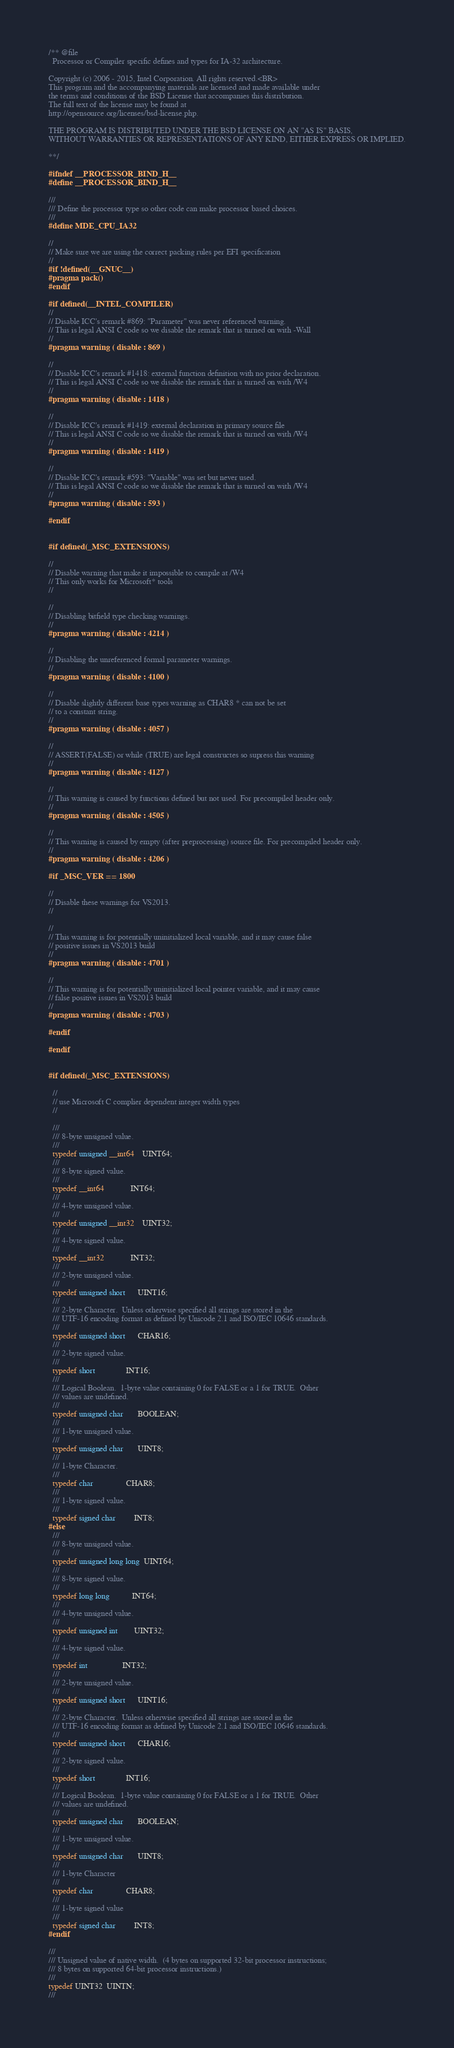<code> <loc_0><loc_0><loc_500><loc_500><_C_>/** @file
  Processor or Compiler specific defines and types for IA-32 architecture.

Copyright (c) 2006 - 2015, Intel Corporation. All rights reserved.<BR>
This program and the accompanying materials are licensed and made available under
the terms and conditions of the BSD License that accompanies this distribution.
The full text of the license may be found at
http://opensource.org/licenses/bsd-license.php.

THE PROGRAM IS DISTRIBUTED UNDER THE BSD LICENSE ON AN "AS IS" BASIS,
WITHOUT WARRANTIES OR REPRESENTATIONS OF ANY KIND, EITHER EXPRESS OR IMPLIED.

**/

#ifndef __PROCESSOR_BIND_H__
#define __PROCESSOR_BIND_H__

///
/// Define the processor type so other code can make processor based choices.
///
#define MDE_CPU_IA32

//
// Make sure we are using the correct packing rules per EFI specification
//
#if !defined(__GNUC__)
#pragma pack()
#endif

#if defined(__INTEL_COMPILER)
//
// Disable ICC's remark #869: "Parameter" was never referenced warning.
// This is legal ANSI C code so we disable the remark that is turned on with -Wall
//
#pragma warning ( disable : 869 )

//
// Disable ICC's remark #1418: external function definition with no prior declaration.
// This is legal ANSI C code so we disable the remark that is turned on with /W4
//
#pragma warning ( disable : 1418 )

//
// Disable ICC's remark #1419: external declaration in primary source file
// This is legal ANSI C code so we disable the remark that is turned on with /W4
//
#pragma warning ( disable : 1419 )

//
// Disable ICC's remark #593: "Variable" was set but never used.
// This is legal ANSI C code so we disable the remark that is turned on with /W4
//
#pragma warning ( disable : 593 )

#endif


#if defined(_MSC_EXTENSIONS)

//
// Disable warning that make it impossible to compile at /W4
// This only works for Microsoft* tools
//

//
// Disabling bitfield type checking warnings.
//
#pragma warning ( disable : 4214 )

//
// Disabling the unreferenced formal parameter warnings.
//
#pragma warning ( disable : 4100 )

//
// Disable slightly different base types warning as CHAR8 * can not be set
// to a constant string.
//
#pragma warning ( disable : 4057 )

//
// ASSERT(FALSE) or while (TRUE) are legal constructes so supress this warning
//
#pragma warning ( disable : 4127 )

//
// This warning is caused by functions defined but not used. For precompiled header only.
//
#pragma warning ( disable : 4505 )

//
// This warning is caused by empty (after preprocessing) source file. For precompiled header only.
//
#pragma warning ( disable : 4206 )

#if _MSC_VER == 1800

//
// Disable these warnings for VS2013.
//

//
// This warning is for potentially uninitialized local variable, and it may cause false
// positive issues in VS2013 build
//
#pragma warning ( disable : 4701 )

//
// This warning is for potentially uninitialized local pointer variable, and it may cause
// false positive issues in VS2013 build
//
#pragma warning ( disable : 4703 )

#endif

#endif


#if defined(_MSC_EXTENSIONS)

  //
  // use Microsoft C complier dependent integer width types
  //

  ///
  /// 8-byte unsigned value.
  ///
  typedef unsigned __int64    UINT64;
  ///
  /// 8-byte signed value.
  ///
  typedef __int64             INT64;
  ///
  /// 4-byte unsigned value.
  ///
  typedef unsigned __int32    UINT32;
  ///
  /// 4-byte signed value.
  ///
  typedef __int32             INT32;
  ///
  /// 2-byte unsigned value.
  ///
  typedef unsigned short      UINT16;
  ///
  /// 2-byte Character.  Unless otherwise specified all strings are stored in the
  /// UTF-16 encoding format as defined by Unicode 2.1 and ISO/IEC 10646 standards.
  ///
  typedef unsigned short      CHAR16;
  ///
  /// 2-byte signed value.
  ///
  typedef short               INT16;
  ///
  /// Logical Boolean.  1-byte value containing 0 for FALSE or a 1 for TRUE.  Other
  /// values are undefined.
  ///
  typedef unsigned char       BOOLEAN;
  ///
  /// 1-byte unsigned value.
  ///
  typedef unsigned char       UINT8;
  ///
  /// 1-byte Character.
  ///
  typedef char                CHAR8;
  ///
  /// 1-byte signed value.
  ///
  typedef signed char         INT8;
#else
  ///
  /// 8-byte unsigned value.
  ///
  typedef unsigned long long  UINT64;
  ///
  /// 8-byte signed value.
  ///
  typedef long long           INT64;
  ///
  /// 4-byte unsigned value.
  ///
  typedef unsigned int        UINT32;
  ///
  /// 4-byte signed value.
  ///
  typedef int                 INT32;
  ///
  /// 2-byte unsigned value.
  ///
  typedef unsigned short      UINT16;
  ///
  /// 2-byte Character.  Unless otherwise specified all strings are stored in the
  /// UTF-16 encoding format as defined by Unicode 2.1 and ISO/IEC 10646 standards.
  ///
  typedef unsigned short      CHAR16;
  ///
  /// 2-byte signed value.
  ///
  typedef short               INT16;
  ///
  /// Logical Boolean.  1-byte value containing 0 for FALSE or a 1 for TRUE.  Other
  /// values are undefined.
  ///
  typedef unsigned char       BOOLEAN;
  ///
  /// 1-byte unsigned value.
  ///
  typedef unsigned char       UINT8;
  ///
  /// 1-byte Character
  ///
  typedef char                CHAR8;
  ///
  /// 1-byte signed value
  ///
  typedef signed char         INT8;
#endif

///
/// Unsigned value of native width.  (4 bytes on supported 32-bit processor instructions;
/// 8 bytes on supported 64-bit processor instructions.)
///
typedef UINT32  UINTN;
///</code> 